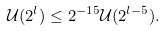<formula> <loc_0><loc_0><loc_500><loc_500>\mathcal { U } ( 2 ^ { l } ) \leq 2 ^ { - 1 5 } \mathcal { U } ( 2 ^ { l - 5 } ) .</formula> 